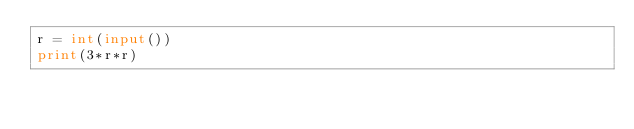Convert code to text. <code><loc_0><loc_0><loc_500><loc_500><_Python_>r = int(input())
print(3*r*r)</code> 